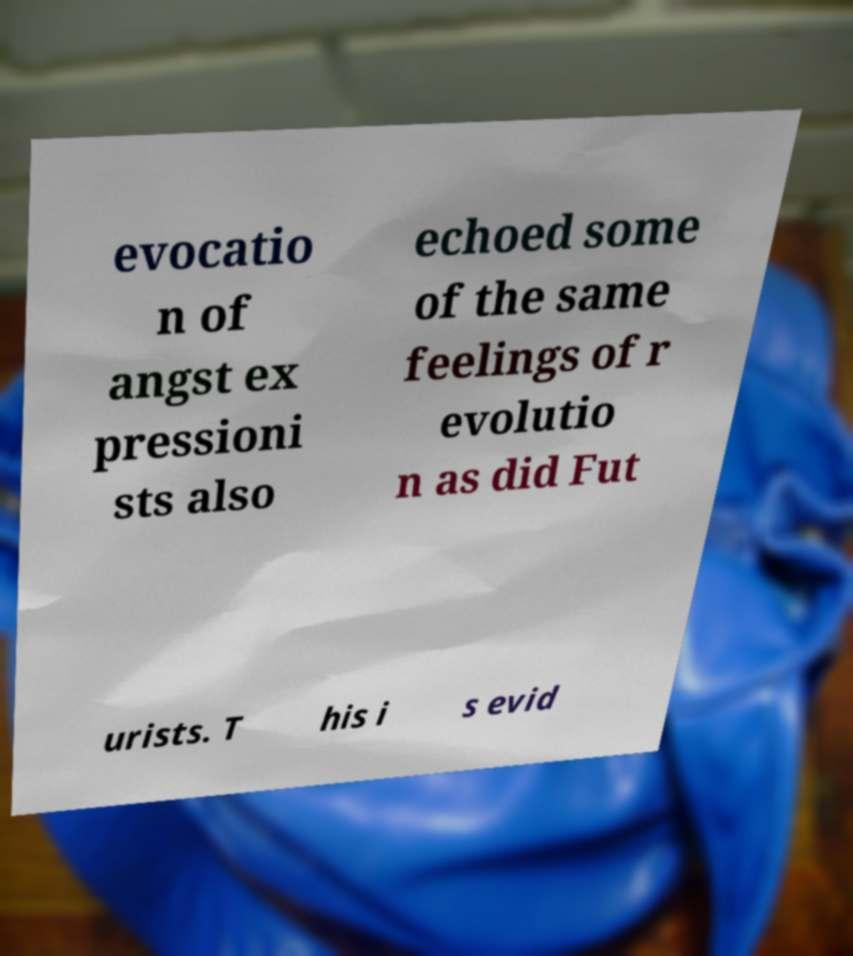Could you assist in decoding the text presented in this image and type it out clearly? evocatio n of angst ex pressioni sts also echoed some of the same feelings of r evolutio n as did Fut urists. T his i s evid 